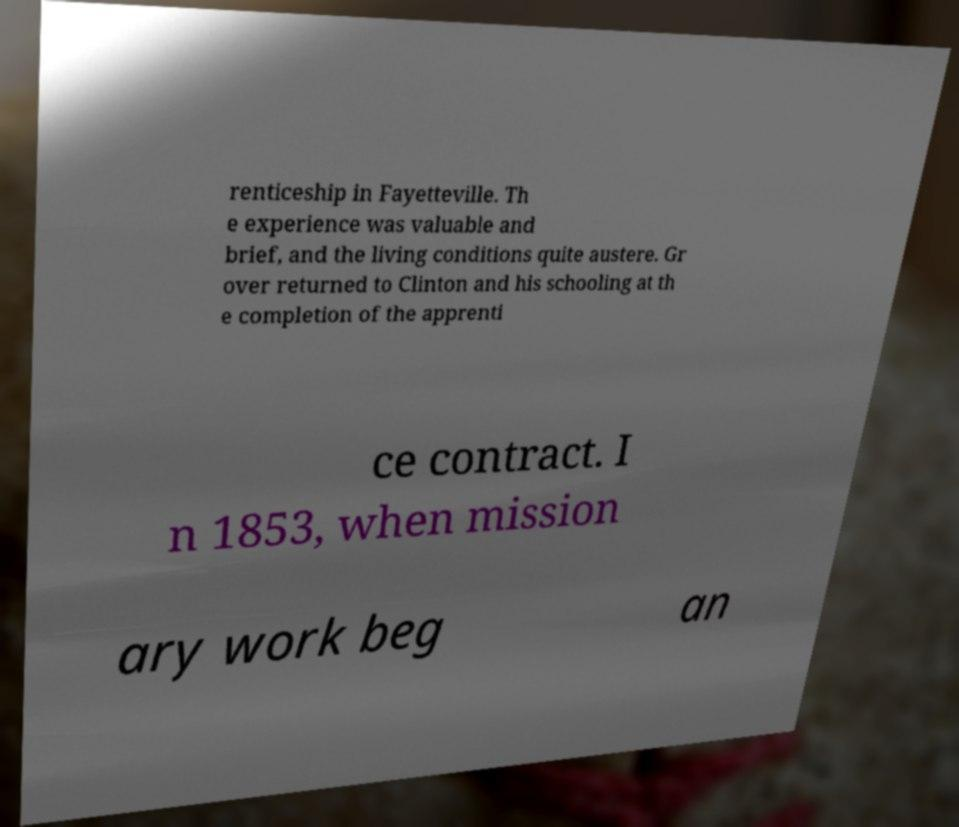Please identify and transcribe the text found in this image. renticeship in Fayetteville. Th e experience was valuable and brief, and the living conditions quite austere. Gr over returned to Clinton and his schooling at th e completion of the apprenti ce contract. I n 1853, when mission ary work beg an 